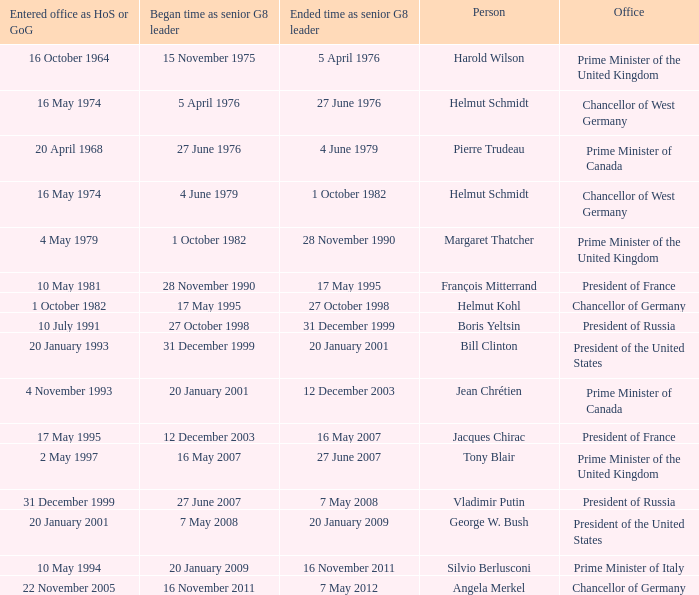When did Jacques Chirac stop being a G8 leader? 16 May 2007. 